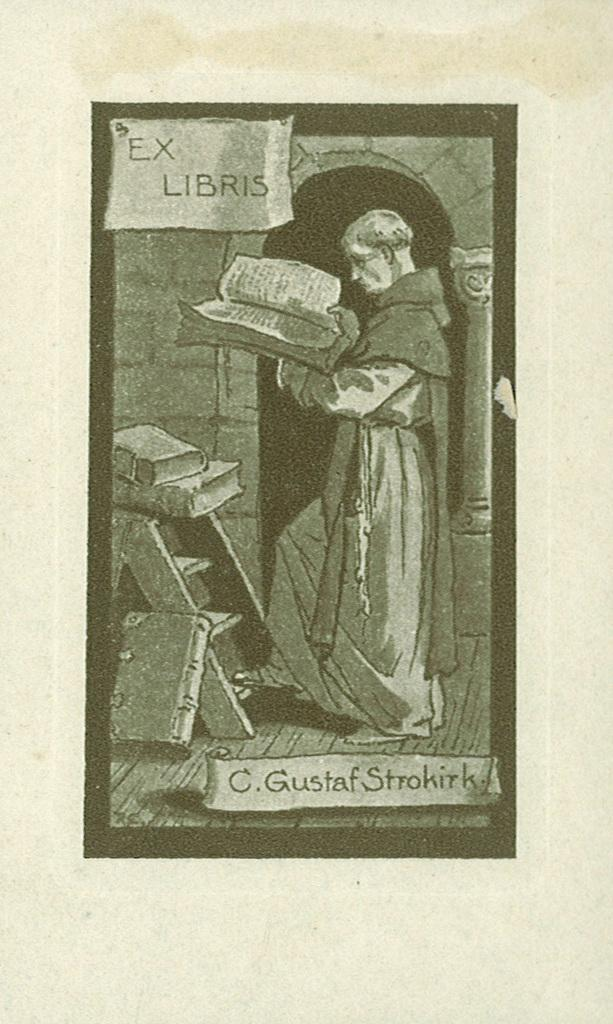Who is present in the image? There is a person in the image. What is the person holding? The person is holding a book. What else can be seen in the image besides the person? There is a ladder in the image. What is on the ladder? There are books on the ladder. What type of drain is visible in the image? There is no drain present in the image. How does the person's boot contribute to the image? There is no mention of a boot in the image, so it cannot contribute to the image. 